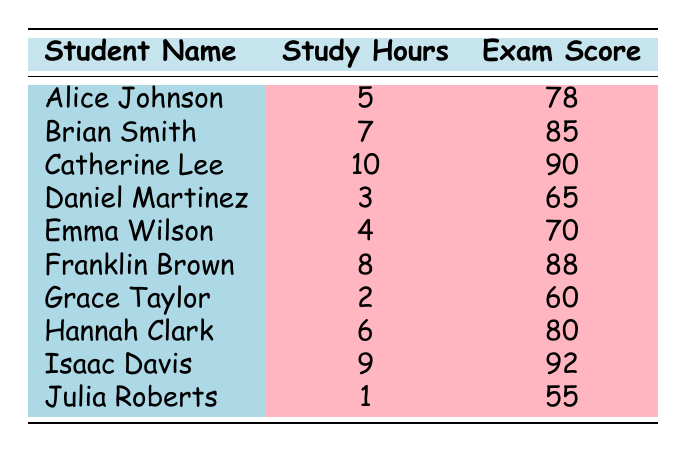What is the exam score of Hannah Clark? From the table, we can see that Hannah Clark has an exam score listed next to her name, which is 80.
Answer: 80 Which student studied the most hours in a week? By looking at the study hours column, we can identify that Catherine Lee studied 10 hours, which is the highest among all listed students.
Answer: Catherine Lee Is it true that Grace Taylor scored above 70? By reviewing the exam scores, Grace Taylor has a score of 60, which is below 70; therefore, the statement is false.
Answer: No What is the average exam score of students who studied more than 5 hours? The students who studied more than 5 hours are Brian Smith (85), Catherine Lee (90), Franklin Brown (88), Hannah Clark (80), and Isaac Davis (92). Summing these scores (85 + 90 + 88 + 80 + 92) gives 435. There are 5 students, so the average score is 435/5 = 87.
Answer: 87 How many students studied 4 hours or fewer? From the table, we see Grace Taylor (2 hours), Emma Wilson (4 hours), and Julia Roberts (1 hour), totaling 3 students who studied 4 hours or fewer.
Answer: 3 What is the difference in exam scores between the student with the highest score and the student with the lowest? The student with the highest score is Isaac Davis with 92, and the lowest is Julia Roberts with 55. The difference is 92 - 55 = 37.
Answer: 37 Who scored the same as the number of hours they studied? By examining the scores, we find that Emma Wilson studied 4 hours and scored 70. Other students do not meet this criterion.
Answer: Emma Wilson Which student had the least amount of study hours, and what was their exam score? Looking at the weekly study hours, Grace Taylor had the least hours at 2, and her exam score is 60.
Answer: Grace Taylor, 60 